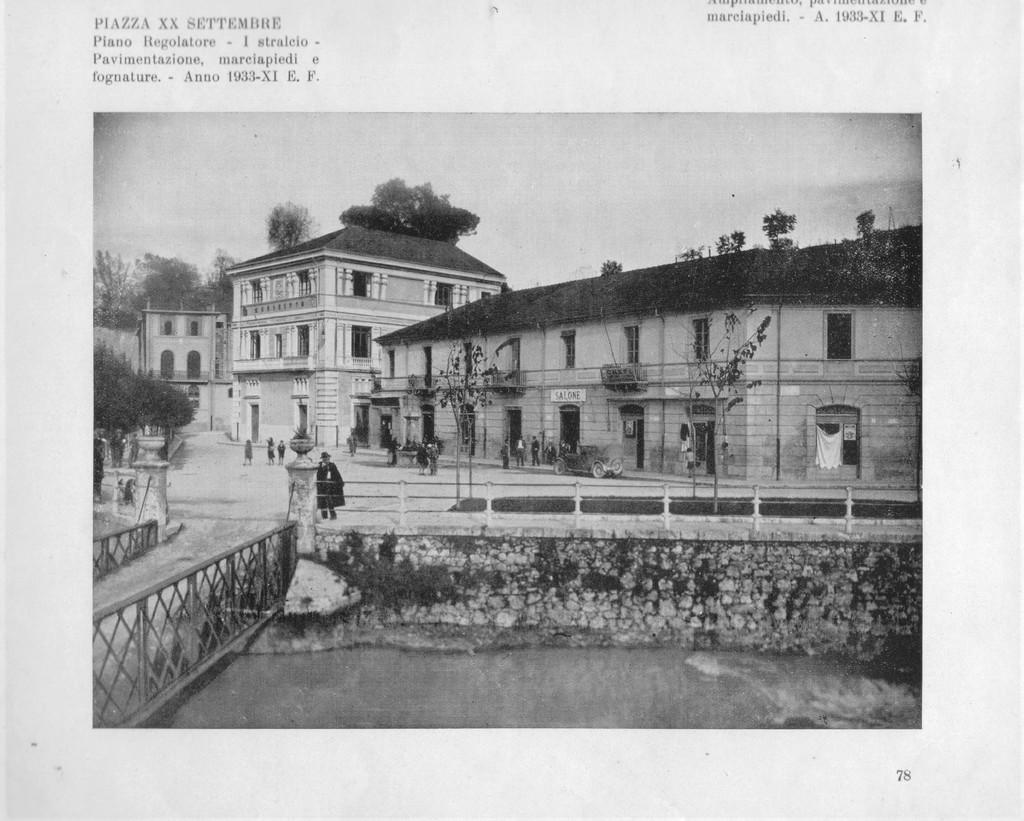What is the color scheme of the image? The image is black and white. What type of structures can be seen in the image? There are buildings in the image. What natural elements are present in the image? There are trees in the image. Are there any people in the image? Yes, there are persons in the image. What type of man-made structure is present in the image? There is a bridge in the image. What mode of transportation can be seen in the image? There is a car in the image. What part of the natural environment is visible in the image? The sky is visible in the image. What type of prose is being recited by the trees in the image? There is no prose being recited by the trees in the image, as trees do not have the ability to speak or recite prose. 